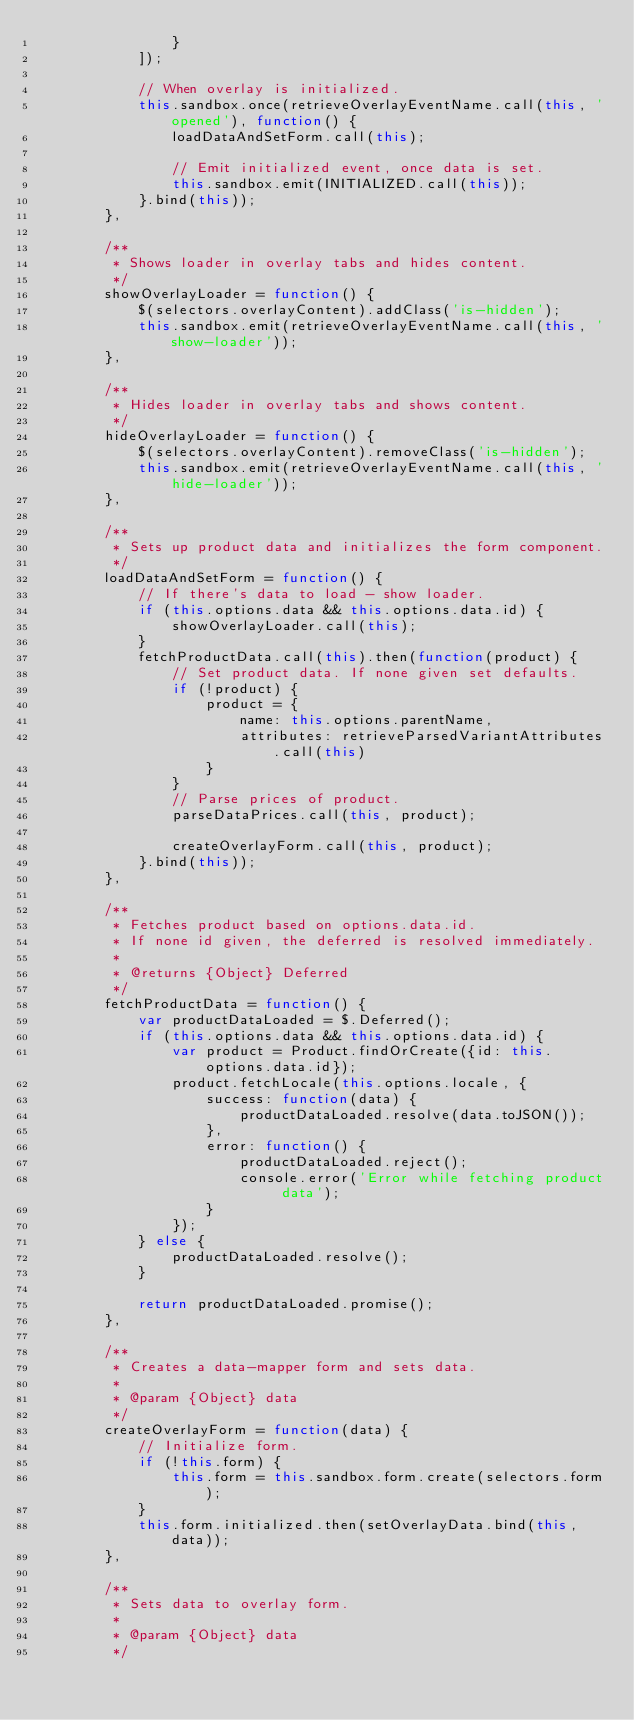<code> <loc_0><loc_0><loc_500><loc_500><_JavaScript_>                }
            ]);

            // When overlay is initialized.
            this.sandbox.once(retrieveOverlayEventName.call(this, 'opened'), function() {
                loadDataAndSetForm.call(this);

                // Emit initialized event, once data is set.
                this.sandbox.emit(INITIALIZED.call(this));
            }.bind(this));
        },

        /**
         * Shows loader in overlay tabs and hides content.
         */
        showOverlayLoader = function() {
            $(selectors.overlayContent).addClass('is-hidden');
            this.sandbox.emit(retrieveOverlayEventName.call(this, 'show-loader'));
        },

        /**
         * Hides loader in overlay tabs and shows content.
         */
        hideOverlayLoader = function() {
            $(selectors.overlayContent).removeClass('is-hidden');
            this.sandbox.emit(retrieveOverlayEventName.call(this, 'hide-loader'));
        },

        /**
         * Sets up product data and initializes the form component.
         */
        loadDataAndSetForm = function() {
            // If there's data to load - show loader.
            if (this.options.data && this.options.data.id) {
                showOverlayLoader.call(this);
            }
            fetchProductData.call(this).then(function(product) {
                // Set product data. If none given set defaults.
                if (!product) {
                    product = {
                        name: this.options.parentName,
                        attributes: retrieveParsedVariantAttributes.call(this)
                    }
                }
                // Parse prices of product.
                parseDataPrices.call(this, product);

                createOverlayForm.call(this, product);
            }.bind(this));
        },

        /**
         * Fetches product based on options.data.id.
         * If none id given, the deferred is resolved immediately.
         *
         * @returns {Object} Deferred
         */
        fetchProductData = function() {
            var productDataLoaded = $.Deferred();
            if (this.options.data && this.options.data.id) {
                var product = Product.findOrCreate({id: this.options.data.id});
                product.fetchLocale(this.options.locale, {
                    success: function(data) {
                        productDataLoaded.resolve(data.toJSON());
                    },
                    error: function() {
                        productDataLoaded.reject();
                        console.error('Error while fetching product data');
                    }
                });
            } else {
                productDataLoaded.resolve();
            }

            return productDataLoaded.promise();
        },

        /**
         * Creates a data-mapper form and sets data.
         *
         * @param {Object} data
         */
        createOverlayForm = function(data) {
            // Initialize form.
            if (!this.form) {
                this.form = this.sandbox.form.create(selectors.form);
            }
            this.form.initialized.then(setOverlayData.bind(this, data));
        },

        /**
         * Sets data to overlay form.
         *
         * @param {Object} data
         */</code> 